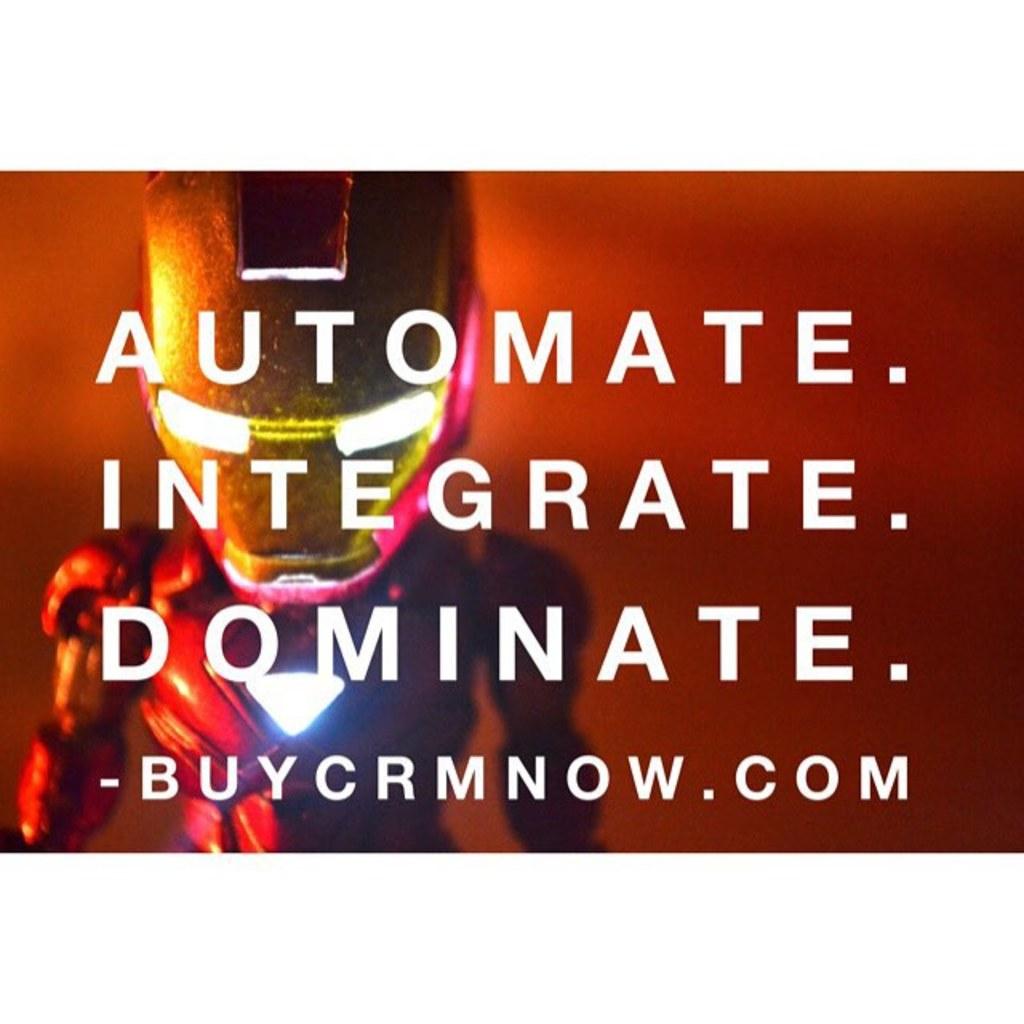What website is shown on this ad?
Your answer should be compact. Buycrmnow.com. 